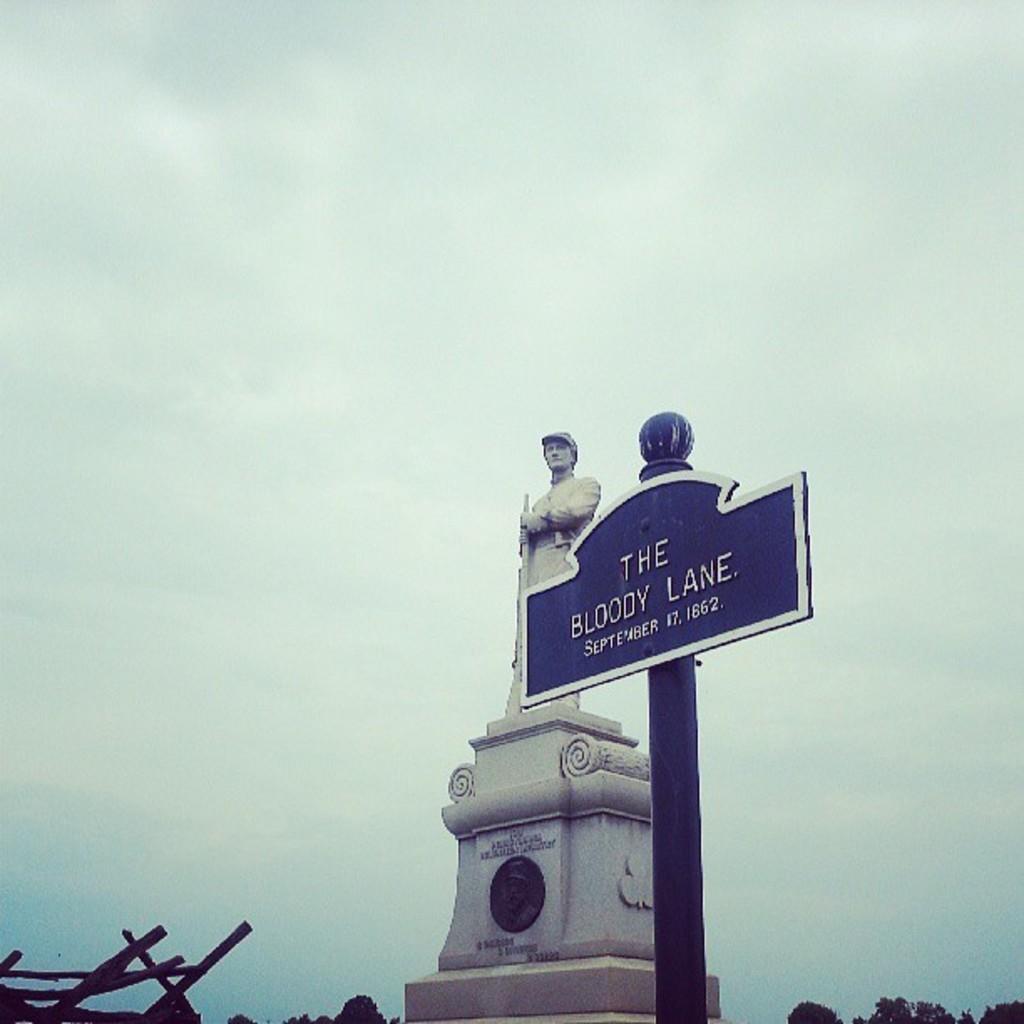Can you describe this image briefly? In this image, we can see a name board with pole, statue. At the bottom, of the image, we can see some sticks and trees. Background there is a sky. 